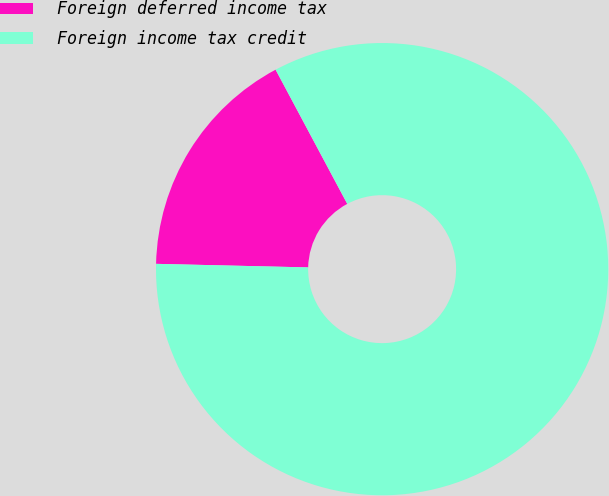Convert chart. <chart><loc_0><loc_0><loc_500><loc_500><pie_chart><fcel>Foreign deferred income tax<fcel>Foreign income tax credit<nl><fcel>16.82%<fcel>83.18%<nl></chart> 